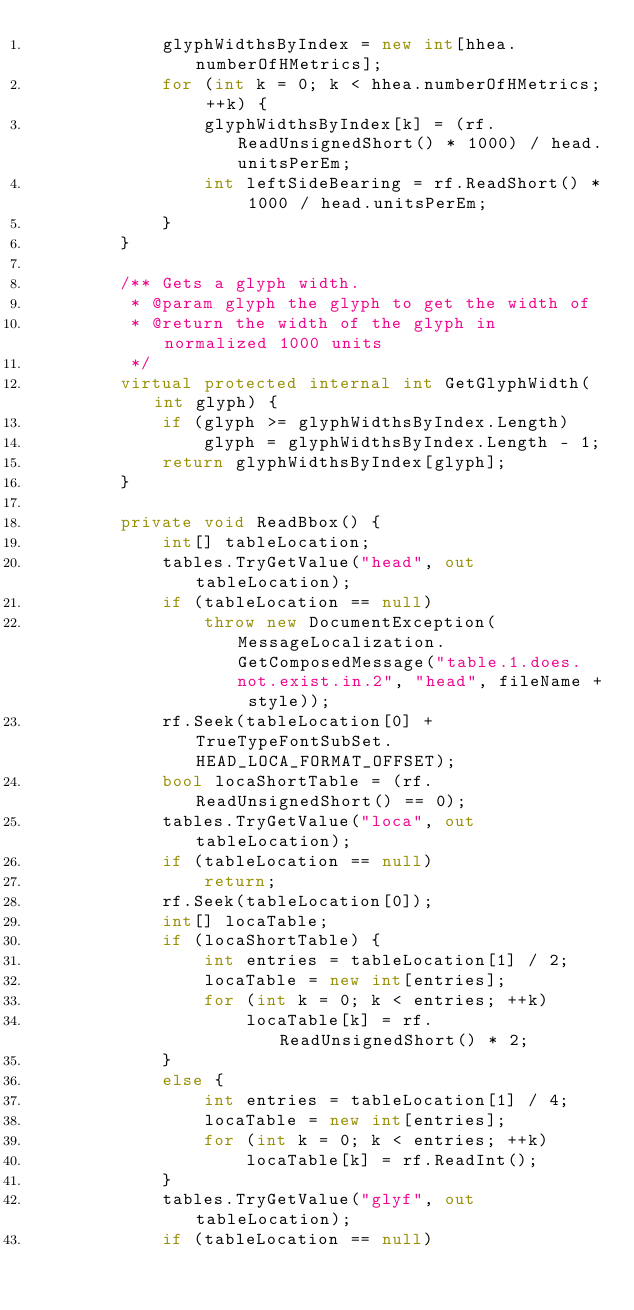Convert code to text. <code><loc_0><loc_0><loc_500><loc_500><_C#_>            glyphWidthsByIndex = new int[hhea.numberOfHMetrics];
            for (int k = 0; k < hhea.numberOfHMetrics; ++k) {
                glyphWidthsByIndex[k] = (rf.ReadUnsignedShort() * 1000) / head.unitsPerEm;
                int leftSideBearing = rf.ReadShort() * 1000 / head.unitsPerEm;
            }
        }
    
        /** Gets a glyph width.
         * @param glyph the glyph to get the width of
         * @return the width of the glyph in normalized 1000 units
         */
        virtual protected internal int GetGlyphWidth(int glyph) {
            if (glyph >= glyphWidthsByIndex.Length)
                glyph = glyphWidthsByIndex.Length - 1;
            return glyphWidthsByIndex[glyph];
        }
    
        private void ReadBbox() {
            int[] tableLocation;
            tables.TryGetValue("head", out tableLocation);
            if (tableLocation == null)
                throw new DocumentException(MessageLocalization.GetComposedMessage("table.1.does.not.exist.in.2", "head", fileName + style));
            rf.Seek(tableLocation[0] + TrueTypeFontSubSet.HEAD_LOCA_FORMAT_OFFSET);
            bool locaShortTable = (rf.ReadUnsignedShort() == 0);
            tables.TryGetValue("loca", out tableLocation);
            if (tableLocation == null)
                return;
            rf.Seek(tableLocation[0]);
            int[] locaTable;
            if (locaShortTable) {
                int entries = tableLocation[1] / 2;
                locaTable = new int[entries];
                for (int k = 0; k < entries; ++k)
                    locaTable[k] = rf.ReadUnsignedShort() * 2;
            }
            else {
                int entries = tableLocation[1] / 4;
                locaTable = new int[entries];
                for (int k = 0; k < entries; ++k)
                    locaTable[k] = rf.ReadInt();
            }
            tables.TryGetValue("glyf", out tableLocation);
            if (tableLocation == null)</code> 